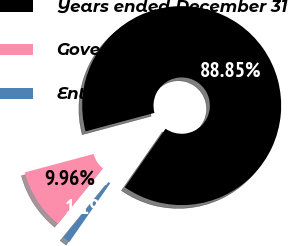Convert chart to OTSL. <chart><loc_0><loc_0><loc_500><loc_500><pie_chart><fcel>Years ended December 31<fcel>Government<fcel>Enterprise<nl><fcel>88.85%<fcel>9.96%<fcel>1.19%<nl></chart> 